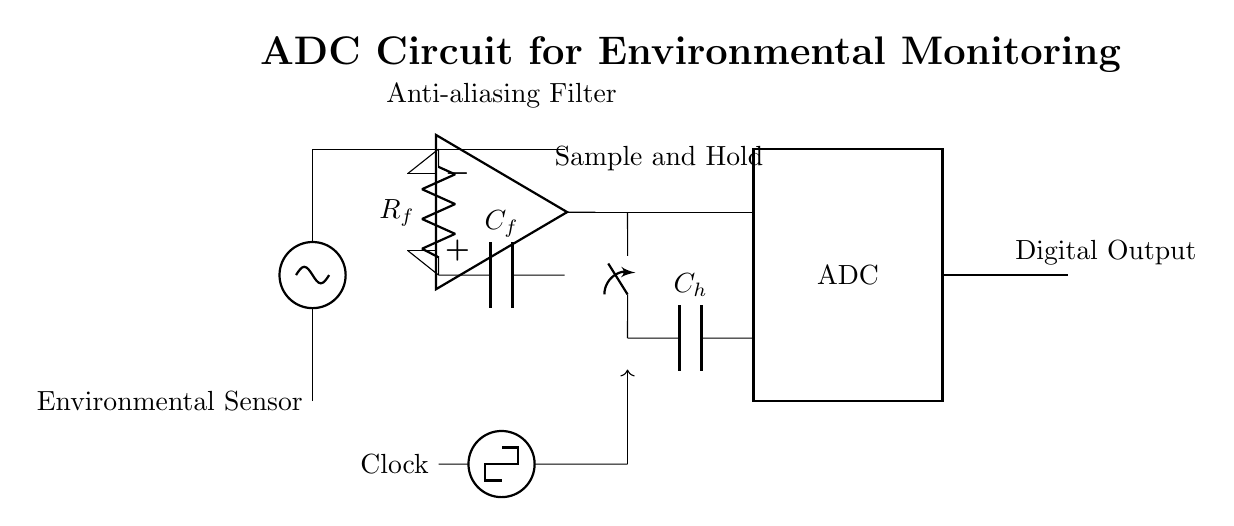What type of filter is used in the circuit? The circuit includes an anti-aliasing filter, which is indicated by the label and the specific components used. This filter prevents high-frequency signals from causing distortion when the signal is sampled.
Answer: Anti-aliasing filter What capacitor is used in the sample and hold section? In the sample and hold section, the capacitor connected is labeled C_h, which signifies that it is a relevant component for maintaining a stable voltage during the sampling process.
Answer: C_h How many main sections are there in this ADC circuit? The ADC circuit consists of three main sections: the anti-aliasing filter, the sample and hold, and the ADC itself. These sections perform different functions crucial for converting analog signals to digital form.
Answer: Three What is the function of the clock in this circuit? The clock provides timing signals to the circuit, ensuring that the sampling and conversion processes occur at the correct intervals. It is essential for synchronizing the operation of the ADC with the input signals.
Answer: Timing signals Which component connects the ADC to the digital output? The connection from the output of the ADC to the digital output is represented by a thick line leading to a labeled node, indicating that this is the pathway through which the converted digital information exits the circuit.
Answer: ADC What is the primary purpose of this ADC circuit? The primary purpose of this ADC circuit is to convert analog signals from the environmental sensor into digital signals that can be processed by a microcontroller or computer system for monitoring and analysis.
Answer: Convert analog signals 